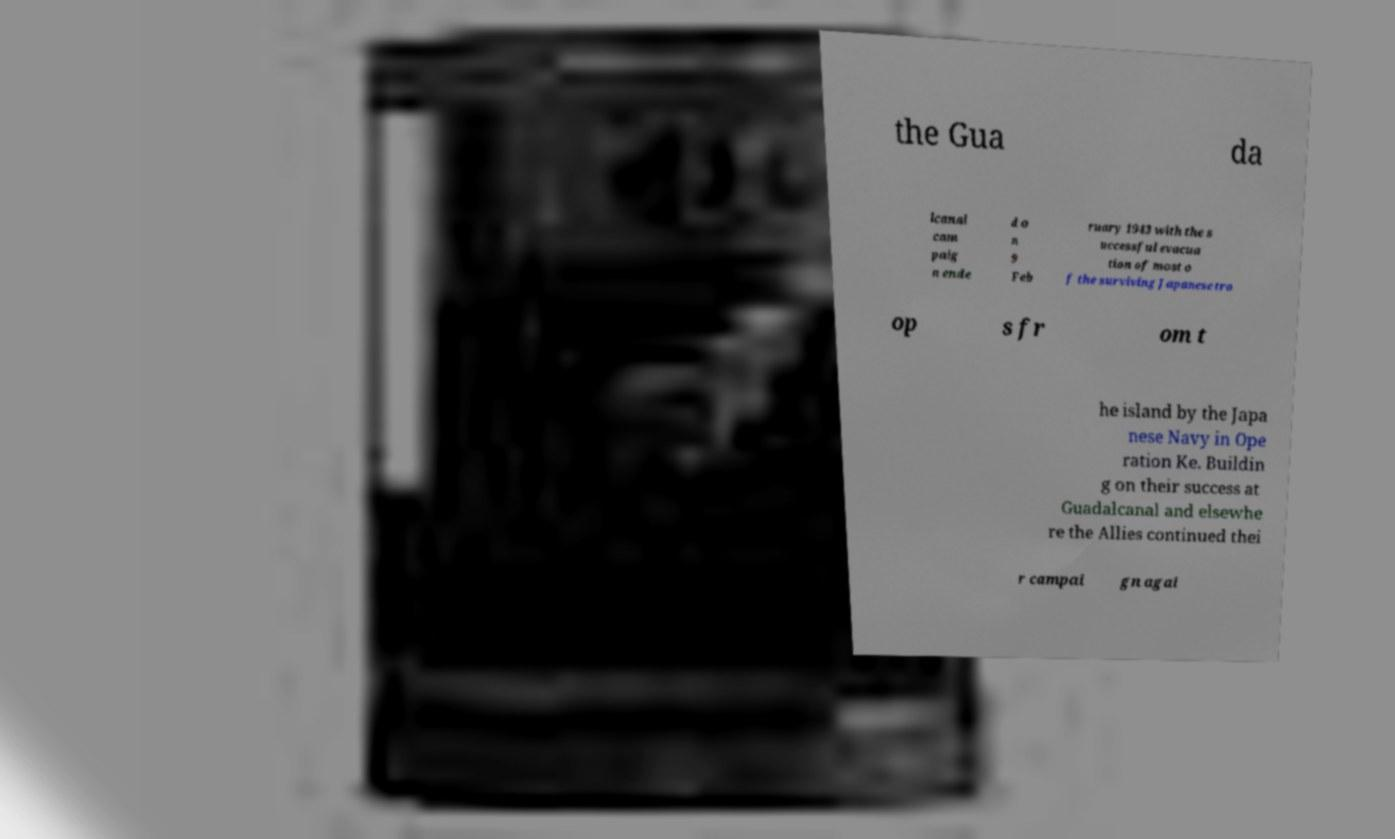Please read and relay the text visible in this image. What does it say? the Gua da lcanal cam paig n ende d o n 9 Feb ruary 1943 with the s uccessful evacua tion of most o f the surviving Japanese tro op s fr om t he island by the Japa nese Navy in Ope ration Ke. Buildin g on their success at Guadalcanal and elsewhe re the Allies continued thei r campai gn agai 